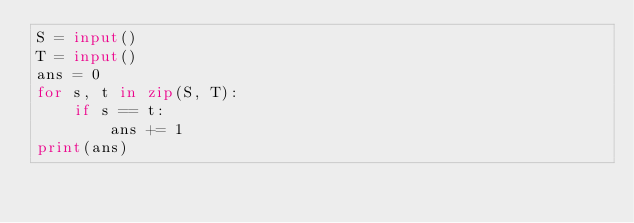Convert code to text. <code><loc_0><loc_0><loc_500><loc_500><_Python_>S = input()
T = input()
ans = 0
for s, t in zip(S, T):
    if s == t:
        ans += 1
print(ans)
</code> 